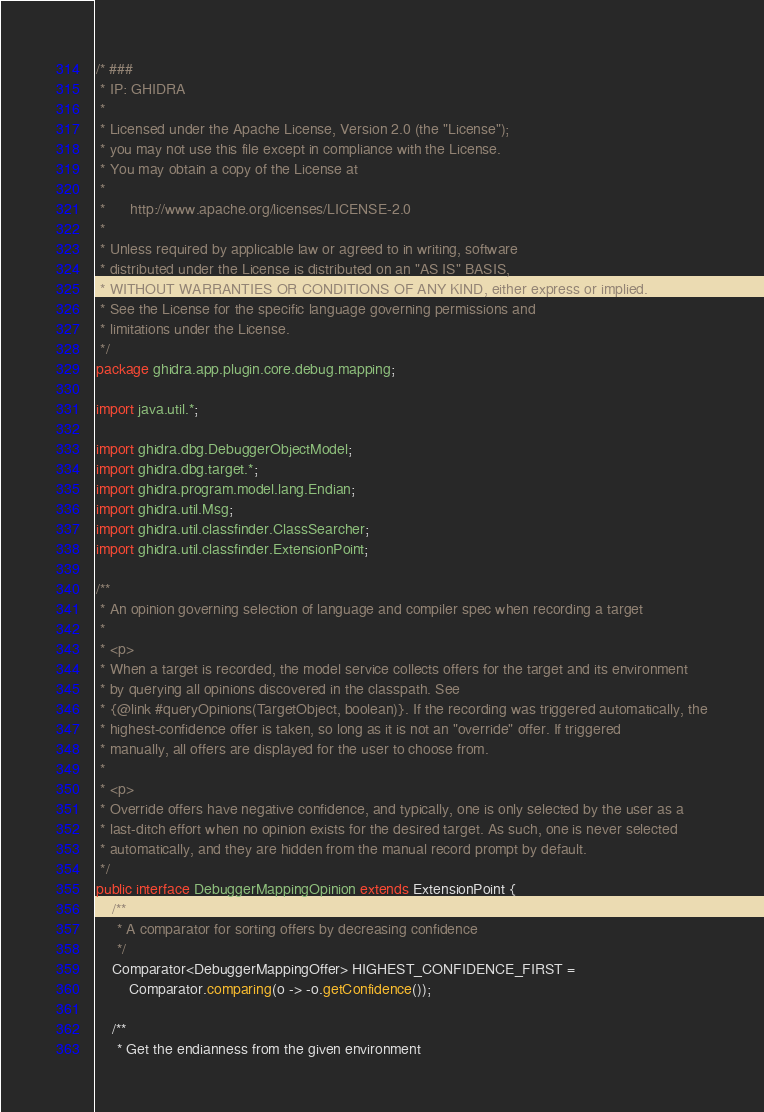<code> <loc_0><loc_0><loc_500><loc_500><_Java_>/* ###
 * IP: GHIDRA
 *
 * Licensed under the Apache License, Version 2.0 (the "License");
 * you may not use this file except in compliance with the License.
 * You may obtain a copy of the License at
 * 
 *      http://www.apache.org/licenses/LICENSE-2.0
 * 
 * Unless required by applicable law or agreed to in writing, software
 * distributed under the License is distributed on an "AS IS" BASIS,
 * WITHOUT WARRANTIES OR CONDITIONS OF ANY KIND, either express or implied.
 * See the License for the specific language governing permissions and
 * limitations under the License.
 */
package ghidra.app.plugin.core.debug.mapping;

import java.util.*;

import ghidra.dbg.DebuggerObjectModel;
import ghidra.dbg.target.*;
import ghidra.program.model.lang.Endian;
import ghidra.util.Msg;
import ghidra.util.classfinder.ClassSearcher;
import ghidra.util.classfinder.ExtensionPoint;

/**
 * An opinion governing selection of language and compiler spec when recording a target
 * 
 * <p>
 * When a target is recorded, the model service collects offers for the target and its environment
 * by querying all opinions discovered in the classpath. See
 * {@link #queryOpinions(TargetObject, boolean)}. If the recording was triggered automatically, the
 * highest-confidence offer is taken, so long as it is not an "override" offer. If triggered
 * manually, all offers are displayed for the user to choose from.
 * 
 * <p>
 * Override offers have negative confidence, and typically, one is only selected by the user as a
 * last-ditch effort when no opinion exists for the desired target. As such, one is never selected
 * automatically, and they are hidden from the manual record prompt by default.
 */
public interface DebuggerMappingOpinion extends ExtensionPoint {
	/**
	 * A comparator for sorting offers by decreasing confidence
	 */
	Comparator<DebuggerMappingOffer> HIGHEST_CONFIDENCE_FIRST =
		Comparator.comparing(o -> -o.getConfidence());

	/**
	 * Get the endianness from the given environment</code> 